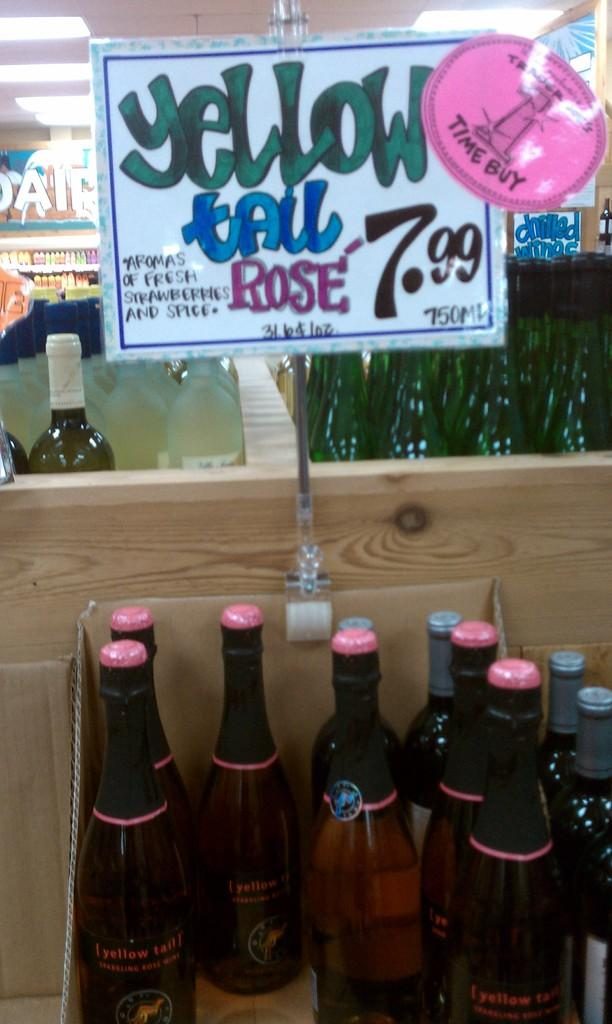<image>
Describe the image concisely. A bottles of Yellow tail rose on sale for 7.99. 